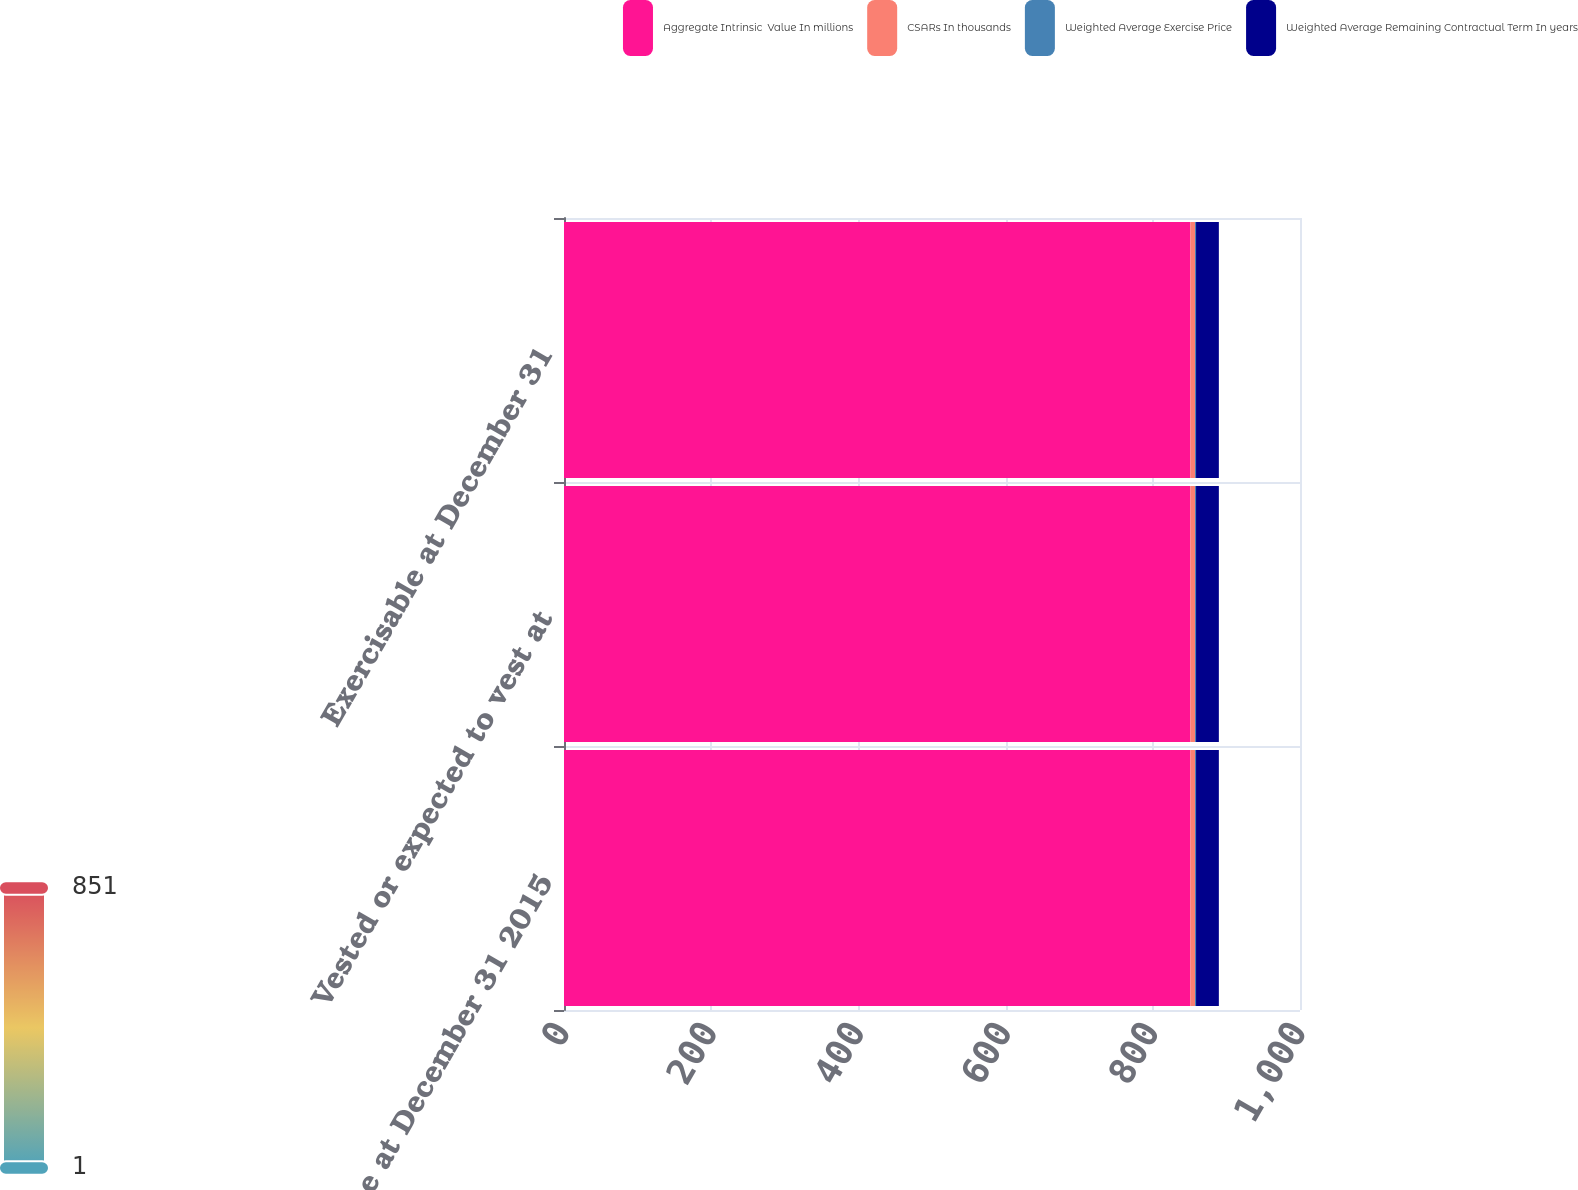<chart> <loc_0><loc_0><loc_500><loc_500><stacked_bar_chart><ecel><fcel>Balance at December 31 2015<fcel>Vested or expected to vest at<fcel>Exercisable at December 31<nl><fcel>Aggregate Intrinsic  Value In millions<fcel>851<fcel>851<fcel>851<nl><fcel>CSARs In thousands<fcel>6.35<fcel>6.35<fcel>6.35<nl><fcel>Weighted Average Exercise Price<fcel>1.4<fcel>1.4<fcel>1.4<nl><fcel>Weighted Average Remaining Contractual Term In years<fcel>31<fcel>31<fcel>31<nl></chart> 